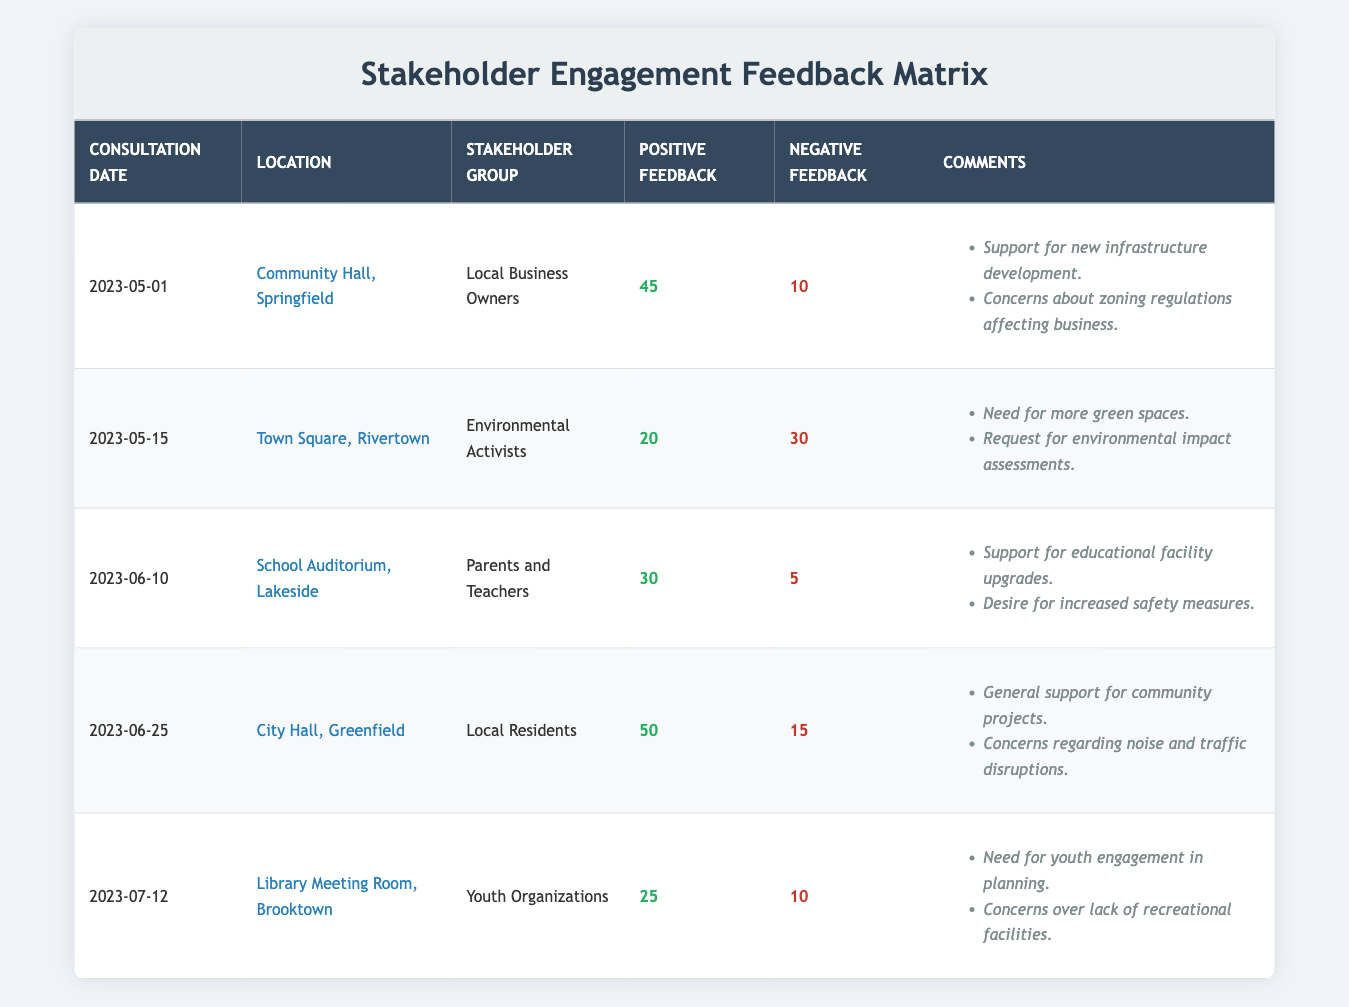What is the total number of positive feedback responses collected from all consultations? To find the total positive feedback, we add up the values from the table: 45 + 20 + 30 + 50 + 25 = 170.
Answer: 170 Which stakeholder group received the highest number of negative feedback responses? Looking at the negative feedback column, Environmental Activists have 30, which is higher than any other group.
Answer: Environmental Activists What is the average number of positive feedback responses across all stakeholder groups? The total positive feedback is 170 and there are 5 groups. Calculating the average gives us 170 / 5 = 34.
Answer: 34 Did Local Residents report more positive feedback than Local Business Owners? Local Residents received 50 positive feedback, while Local Business Owners received 45. Thus, yes, Local Residents reported more.
Answer: Yes What is the difference in feedback positive numbers between Parents and Teachers and Youth Organizations? Parents and Teachers received 30 positive feedback, and Youth Organizations received 25. The difference is 30 - 25 = 5.
Answer: 5 Which consultation had the most comments and what were they? The two consults with comments are Local Business Owners and Environmental Activists with 2 comments each.
Answer: Local Business Owners and Environmental Activists both had 2 comments What percentage of negative feedback did the Local Residents give? Local Residents had 15 negative feedback out of a total of 80 (10+30+5+15+10). The calculation is (15/80) * 100 = 18.75%.
Answer: 18.75% Which group expressed a desire for more green spaces? The Environmental Activists voiced the need for more green spaces, according to their comments.
Answer: Environmental Activists Is there any group that had more positive feedback than negative feedback? Yes, all groups except for Environmental Activists reported more positive feedback than negative.
Answer: Yes 